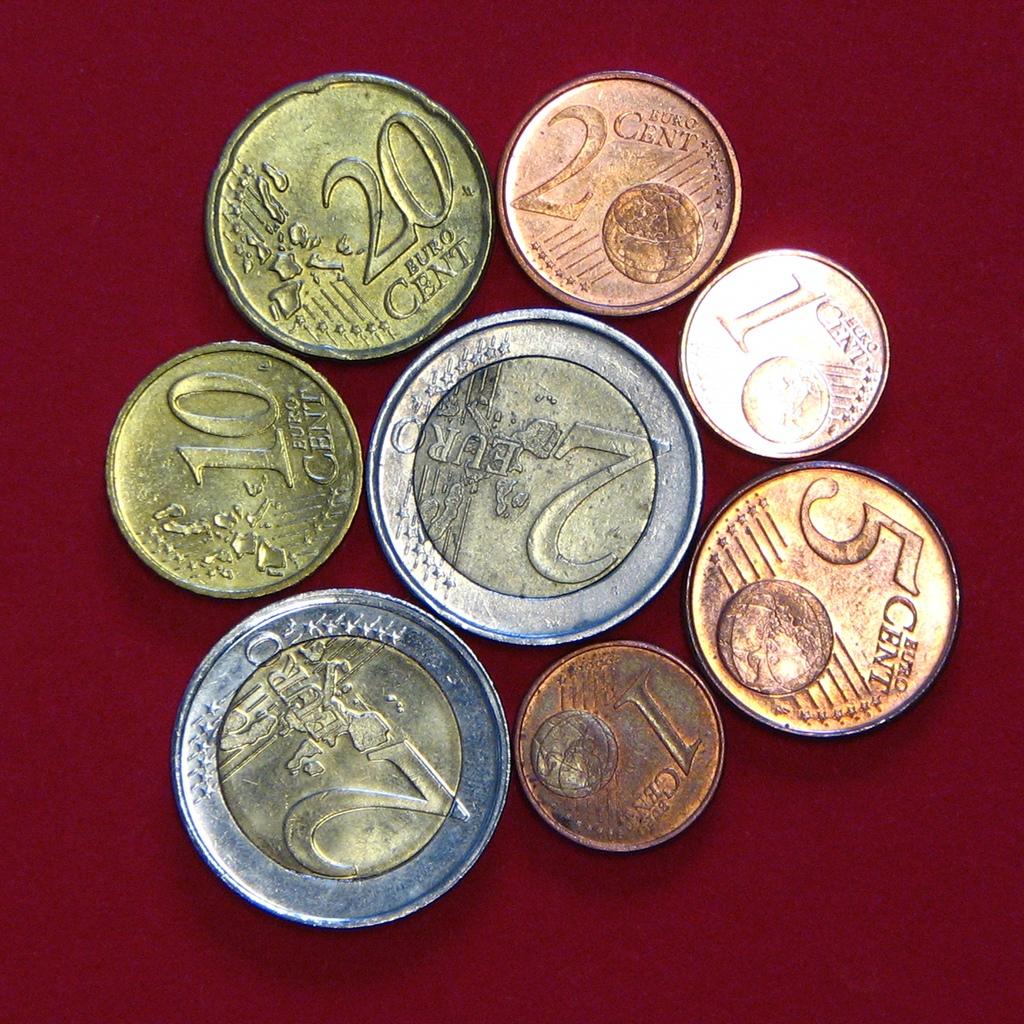What is the total amount of coins here?
Provide a succinct answer. Answering does not require reading text in the image. How much is the coin in the middle worth?
Your answer should be compact. 2 euros. 